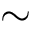<formula> <loc_0><loc_0><loc_500><loc_500>\sim</formula> 